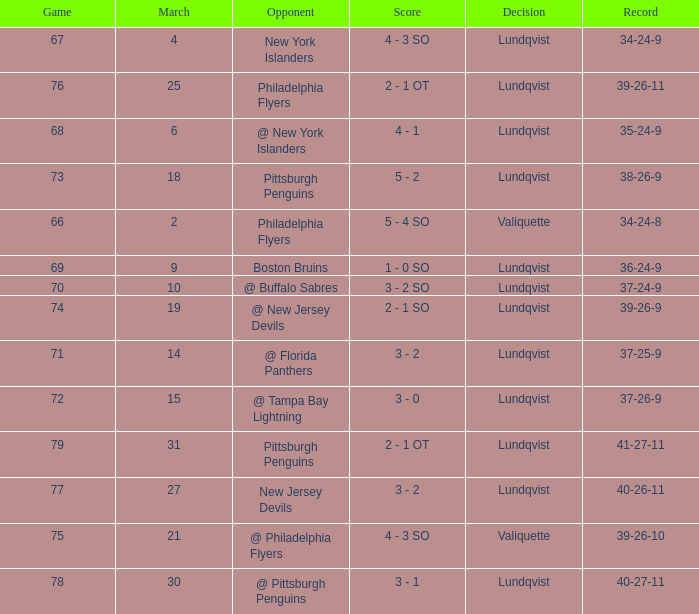Whose march from the opponents was numbered 31? Pittsburgh Penguins. Could you help me parse every detail presented in this table? {'header': ['Game', 'March', 'Opponent', 'Score', 'Decision', 'Record'], 'rows': [['67', '4', 'New York Islanders', '4 - 3 SO', 'Lundqvist', '34-24-9'], ['76', '25', 'Philadelphia Flyers', '2 - 1 OT', 'Lundqvist', '39-26-11'], ['68', '6', '@ New York Islanders', '4 - 1', 'Lundqvist', '35-24-9'], ['73', '18', 'Pittsburgh Penguins', '5 - 2', 'Lundqvist', '38-26-9'], ['66', '2', 'Philadelphia Flyers', '5 - 4 SO', 'Valiquette', '34-24-8'], ['69', '9', 'Boston Bruins', '1 - 0 SO', 'Lundqvist', '36-24-9'], ['70', '10', '@ Buffalo Sabres', '3 - 2 SO', 'Lundqvist', '37-24-9'], ['74', '19', '@ New Jersey Devils', '2 - 1 SO', 'Lundqvist', '39-26-9'], ['71', '14', '@ Florida Panthers', '3 - 2', 'Lundqvist', '37-25-9'], ['72', '15', '@ Tampa Bay Lightning', '3 - 0', 'Lundqvist', '37-26-9'], ['79', '31', 'Pittsburgh Penguins', '2 - 1 OT', 'Lundqvist', '41-27-11'], ['77', '27', 'New Jersey Devils', '3 - 2', 'Lundqvist', '40-26-11'], ['75', '21', '@ Philadelphia Flyers', '4 - 3 SO', 'Valiquette', '39-26-10'], ['78', '30', '@ Pittsburgh Penguins', '3 - 1', 'Lundqvist', '40-27-11']]} 